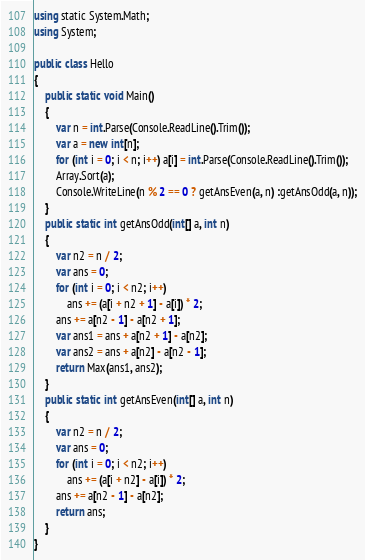<code> <loc_0><loc_0><loc_500><loc_500><_C#_>using static System.Math;
using System;

public class Hello
{
    public static void Main()
    {
        var n = int.Parse(Console.ReadLine().Trim());
        var a = new int[n];
        for (int i = 0; i < n; i++) a[i] = int.Parse(Console.ReadLine().Trim());
        Array.Sort(a);
        Console.WriteLine(n % 2 == 0 ? getAnsEven(a, n) :getAnsOdd(a, n));
    }
    public static int getAnsOdd(int[] a, int n)
    {
        var n2 = n / 2;
        var ans = 0;
        for (int i = 0; i < n2; i++)
            ans += (a[i + n2 + 1] - a[i]) * 2;
        ans += a[n2 - 1] - a[n2 + 1];
        var ans1 = ans + a[n2 + 1] - a[n2];
        var ans2 = ans + a[n2] - a[n2 - 1];
        return Max(ans1, ans2);
    }
    public static int getAnsEven(int[] a, int n)
    {
        var n2 = n / 2;
        var ans = 0;
        for (int i = 0; i < n2; i++)
            ans += (a[i + n2] - a[i]) * 2;
        ans += a[n2 - 1] - a[n2];
        return ans;
    }
}
</code> 